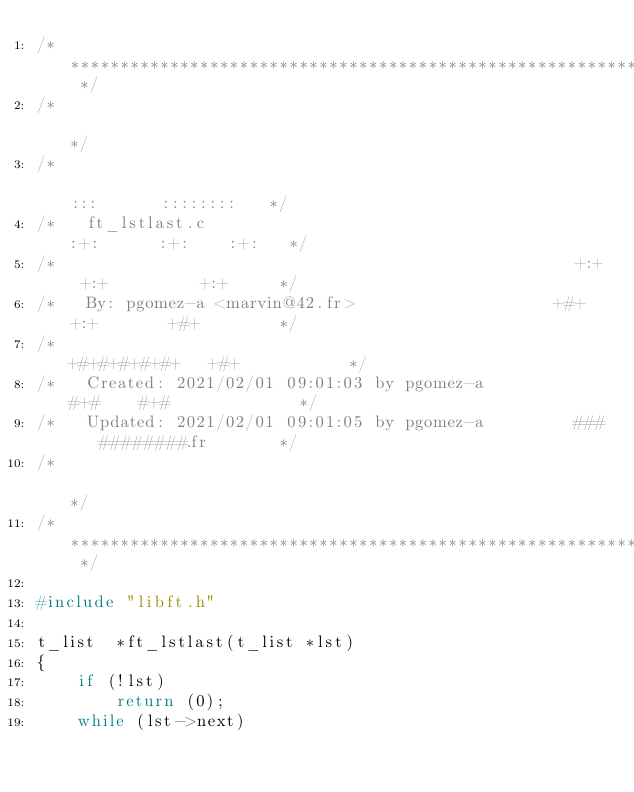<code> <loc_0><loc_0><loc_500><loc_500><_C_>/* ************************************************************************** */
/*                                                                            */
/*                                                        :::      ::::::::   */
/*   ft_lstlast.c                                       :+:      :+:    :+:   */
/*                                                    +:+ +:+         +:+     */
/*   By: pgomez-a <marvin@42.fr>                    +#+  +:+       +#+        */
/*                                                +#+#+#+#+#+   +#+           */
/*   Created: 2021/02/01 09:01:03 by pgomez-a          #+#    #+#             */
/*   Updated: 2021/02/01 09:01:05 by pgomez-a         ###   ########.fr       */
/*                                                                            */
/* ************************************************************************** */

#include "libft.h"

t_list	*ft_lstlast(t_list *lst)
{
	if (!lst)
		return (0);
	while (lst->next)</code> 